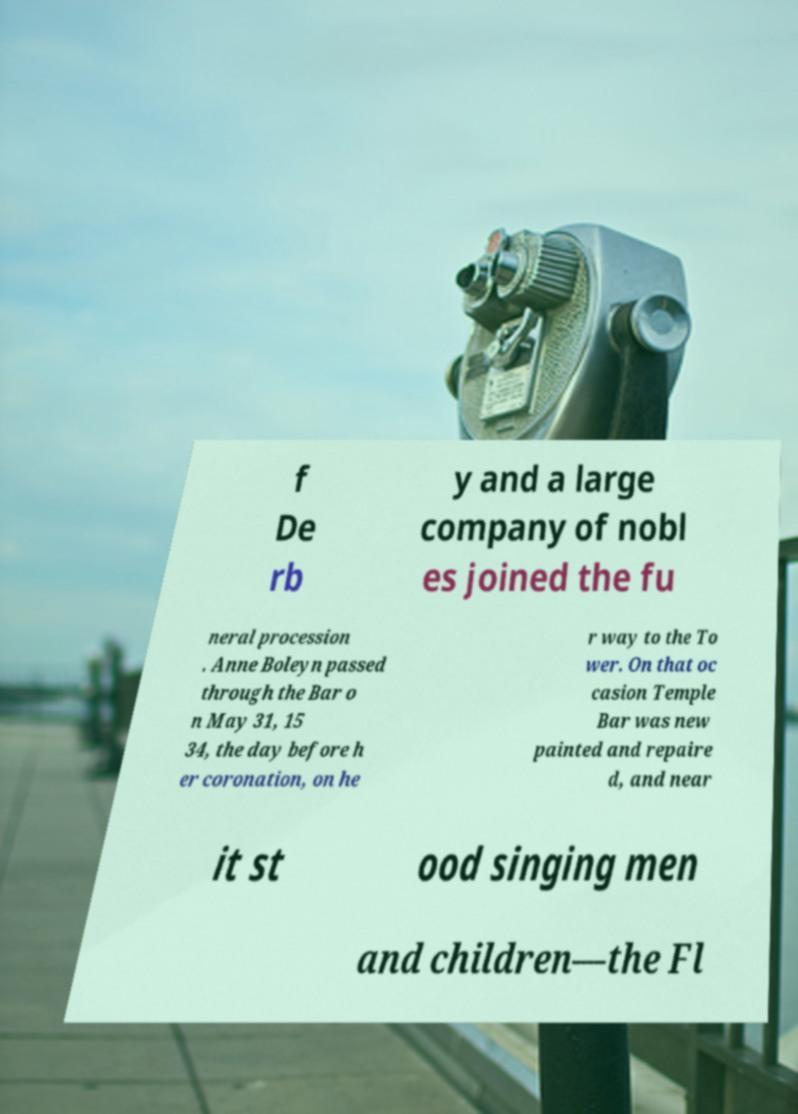I need the written content from this picture converted into text. Can you do that? f De rb y and a large company of nobl es joined the fu neral procession . Anne Boleyn passed through the Bar o n May 31, 15 34, the day before h er coronation, on he r way to the To wer. On that oc casion Temple Bar was new painted and repaire d, and near it st ood singing men and children—the Fl 